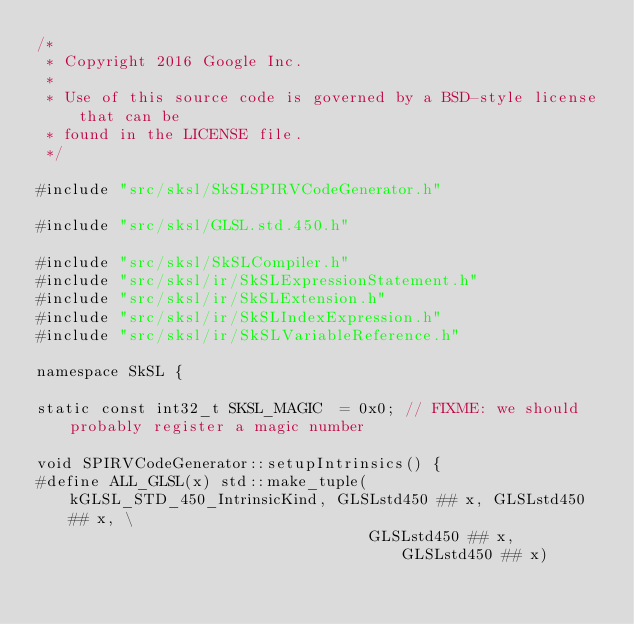Convert code to text. <code><loc_0><loc_0><loc_500><loc_500><_C++_>/*
 * Copyright 2016 Google Inc.
 *
 * Use of this source code is governed by a BSD-style license that can be
 * found in the LICENSE file.
 */

#include "src/sksl/SkSLSPIRVCodeGenerator.h"

#include "src/sksl/GLSL.std.450.h"

#include "src/sksl/SkSLCompiler.h"
#include "src/sksl/ir/SkSLExpressionStatement.h"
#include "src/sksl/ir/SkSLExtension.h"
#include "src/sksl/ir/SkSLIndexExpression.h"
#include "src/sksl/ir/SkSLVariableReference.h"

namespace SkSL {

static const int32_t SKSL_MAGIC  = 0x0; // FIXME: we should probably register a magic number

void SPIRVCodeGenerator::setupIntrinsics() {
#define ALL_GLSL(x) std::make_tuple(kGLSL_STD_450_IntrinsicKind, GLSLstd450 ## x, GLSLstd450 ## x, \
                                    GLSLstd450 ## x, GLSLstd450 ## x)</code> 